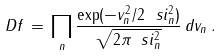Convert formula to latex. <formula><loc_0><loc_0><loc_500><loc_500>\ D f \, = \, \prod _ { n } \frac { \exp ( - v _ { n } ^ { 2 } / 2 \ s i _ { n } ^ { 2 } ) } { \sqrt { 2 \pi \ s i _ { n } ^ { 2 } } } \, d v _ { n } \, .</formula> 